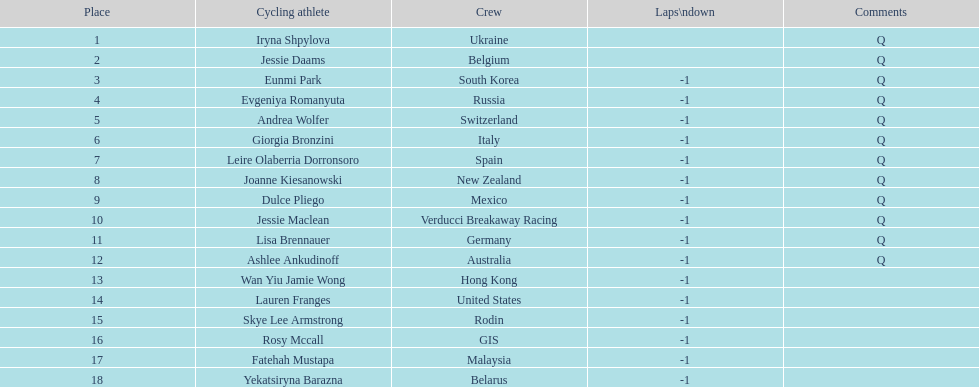What team is listed previous to belgium? Ukraine. 